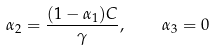<formula> <loc_0><loc_0><loc_500><loc_500>\alpha _ { 2 } = \frac { ( 1 - \alpha _ { 1 } ) C } { \gamma } , \quad \alpha _ { 3 } = 0</formula> 